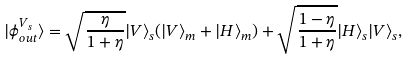Convert formula to latex. <formula><loc_0><loc_0><loc_500><loc_500>| \phi ^ { V _ { s } } _ { o u t } \rangle = \sqrt { \frac { \eta } { 1 + \eta } } | V \rangle _ { s } ( | V \rangle _ { m } + | H \rangle _ { m } ) + \sqrt { \frac { 1 - \eta } { 1 + \eta } } | H \rangle _ { s } | V \rangle _ { s } ,</formula> 